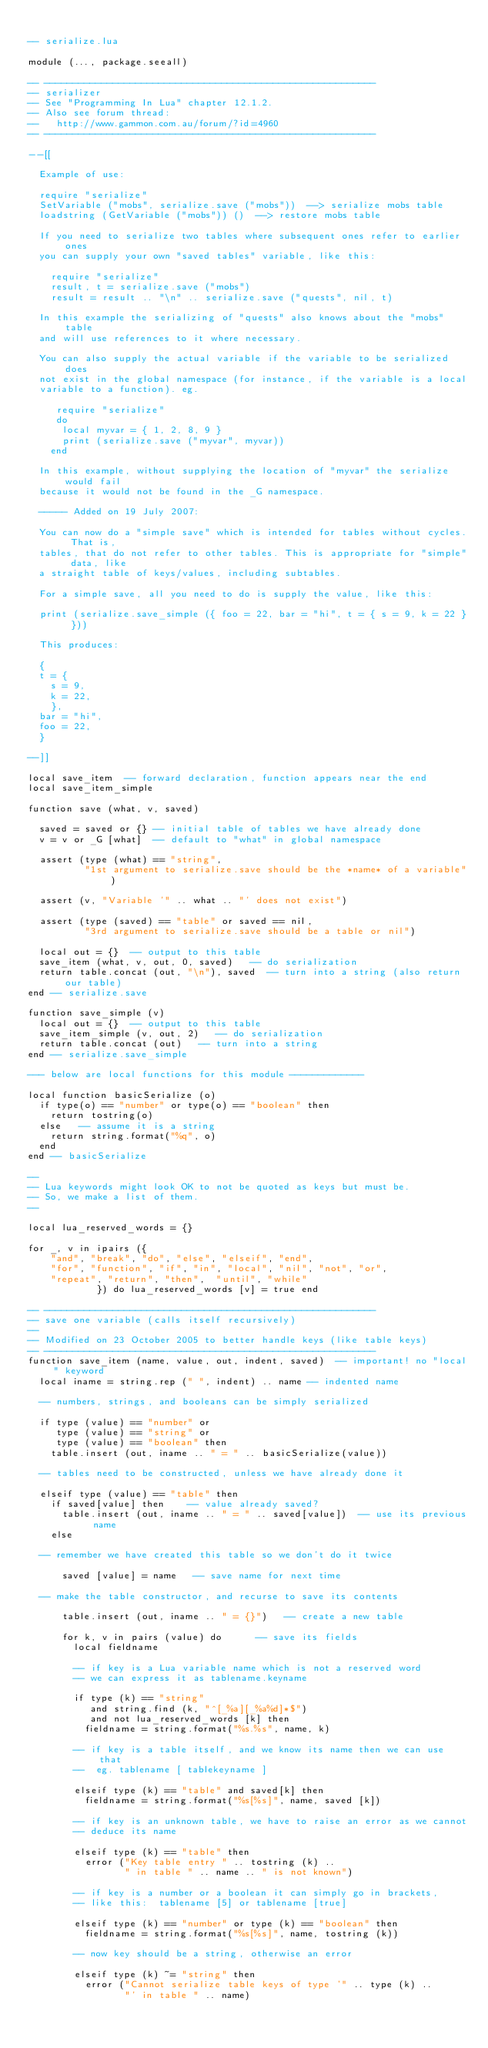Convert code to text. <code><loc_0><loc_0><loc_500><loc_500><_Lua_>
-- serialize.lua

module (..., package.seeall)

-- ----------------------------------------------------------
-- serializer
-- See "Programming In Lua" chapter 12.1.2.
-- Also see forum thread:
--   http://www.gammon.com.au/forum/?id=4960
-- ----------------------------------------------------------

--[[

  Example of use:

  require "serialize"
  SetVariable ("mobs", serialize.save ("mobs"))  --> serialize mobs table
  loadstring (GetVariable ("mobs")) ()  --> restore mobs table 

  If you need to serialize two tables where subsequent ones refer to earlier ones
  you can supply your own "saved tables" variable, like this:

    require "serialize"
    result, t = serialize.save ("mobs")
    result = result .. "\n" .. serialize.save ("quests", nil, t)

  In this example the serializing of "quests" also knows about the "mobs" table
  and will use references to it where necessary.  

  You can also supply the actual variable if the variable to be serialized does
  not exist in the global namespace (for instance, if the variable is a local 
  variable to a function). eg.

     require "serialize"
     do
      local myvar = { 1, 2, 8, 9 }
      print (serialize.save ("myvar", myvar))
    end

  In this example, without supplying the location of "myvar" the serialize would fail
  because it would not be found in the _G namespace.

  ----- Added on 19 July 2007:
  
  You can now do a "simple save" which is intended for tables without cycles. That is,
  tables, that do not refer to other tables. This is appropriate for "simple" data, like
  a straight table of keys/values, including subtables.
  
  For a simple save, all you need to do is supply the value, like this:
  
  print (serialize.save_simple ({ foo = 22, bar = "hi", t = { s = 9, k = 22 } }))
  
  This produces:
  
  {
  t = {
    s = 9,
    k = 22,
    },
  bar = "hi",
  foo = 22,
  }
  
--]]

local save_item  -- forward declaration, function appears near the end
local save_item_simple

function save (what, v, saved)

  saved = saved or {} -- initial table of tables we have already done
  v = v or _G [what]  -- default to "what" in global namespace

  assert (type (what) == "string", 
          "1st argument to serialize.save should be the *name* of a variable")
  
  assert (v, "Variable '" .. what .. "' does not exist")

  assert (type (saved) == "table" or saved == nil, 
          "3rd argument to serialize.save should be a table or nil")

  local out = {}  -- output to this table
  save_item (what, v, out, 0, saved)   -- do serialization
  return table.concat (out, "\n"), saved  -- turn into a string (also return our table)
end -- serialize.save

function save_simple (v)
  local out = {}  -- output to this table
  save_item_simple (v, out, 2)   -- do serialization
  return table.concat (out)   -- turn into a string 
end -- serialize.save_simple

--- below are local functions for this module -------------

local function basicSerialize (o)
  if type(o) == "number" or type(o) == "boolean" then
    return tostring(o)
  else   -- assume it is a string
    return string.format("%q", o)
  end
end -- basicSerialize 

--
-- Lua keywords might look OK to not be quoted as keys but must be.
-- So, we make a list of them.
--

local lua_reserved_words = {}

for _, v in ipairs ({
    "and", "break", "do", "else", "elseif", "end", 
    "for", "function", "if", "in", "local", "nil", "not", "or", 
    "repeat", "return", "then",  "until", "while"
            }) do lua_reserved_words [v] = true end

-- ----------------------------------------------------------
-- save one variable (calls itself recursively)
-- 
-- Modified on 23 October 2005 to better handle keys (like table keys)
-- ----------------------------------------------------------
function save_item (name, value, out, indent, saved)  -- important! no "local" keyword
  local iname = string.rep (" ", indent) .. name -- indented name

  -- numbers, strings, and booleans can be simply serialized

  if type (value) == "number" or 
     type (value) == "string" or
     type (value) == "boolean" then
    table.insert (out, iname .. " = " .. basicSerialize(value))

  -- tables need to be constructed, unless we have already done it

  elseif type (value) == "table" then
    if saved[value] then    -- value already saved?
      table.insert (out, iname .. " = " .. saved[value])  -- use its previous name
    else

  -- remember we have created this table so we don't do it twice

      saved [value] = name   -- save name for next time

  -- make the table constructor, and recurse to save its contents
  
      table.insert (out, iname .. " = {}")   -- create a new table

      for k, v in pairs (value) do      -- save its fields
        local fieldname 

        -- if key is a Lua variable name which is not a reserved word
        -- we can express it as tablename.keyname

        if type (k) == "string"
           and string.find (k, "^[_%a][_%a%d]*$") 
           and not lua_reserved_words [k] then
          fieldname = string.format("%s.%s", name, k)

        -- if key is a table itself, and we know its name then we can use that
        --  eg. tablename [ tablekeyname ]

        elseif type (k) == "table" and saved[k] then
          fieldname = string.format("%s[%s]", name, saved [k]) 

        -- if key is an unknown table, we have to raise an error as we cannot
        -- deduce its name
 
        elseif type (k) == "table" then
          error ("Key table entry " .. tostring (k) .. 
                 " in table " .. name .. " is not known")

        -- if key is a number or a boolean it can simply go in brackets,
        -- like this:  tablename [5] or tablename [true]

        elseif type (k) == "number" or type (k) == "boolean" then
          fieldname = string.format("%s[%s]", name, tostring (k))

        -- now key should be a string, otherwise an error
 
        elseif type (k) ~= "string" then
          error ("Cannot serialize table keys of type '" .. type (k) ..
                 "' in table " .. name)
</code> 